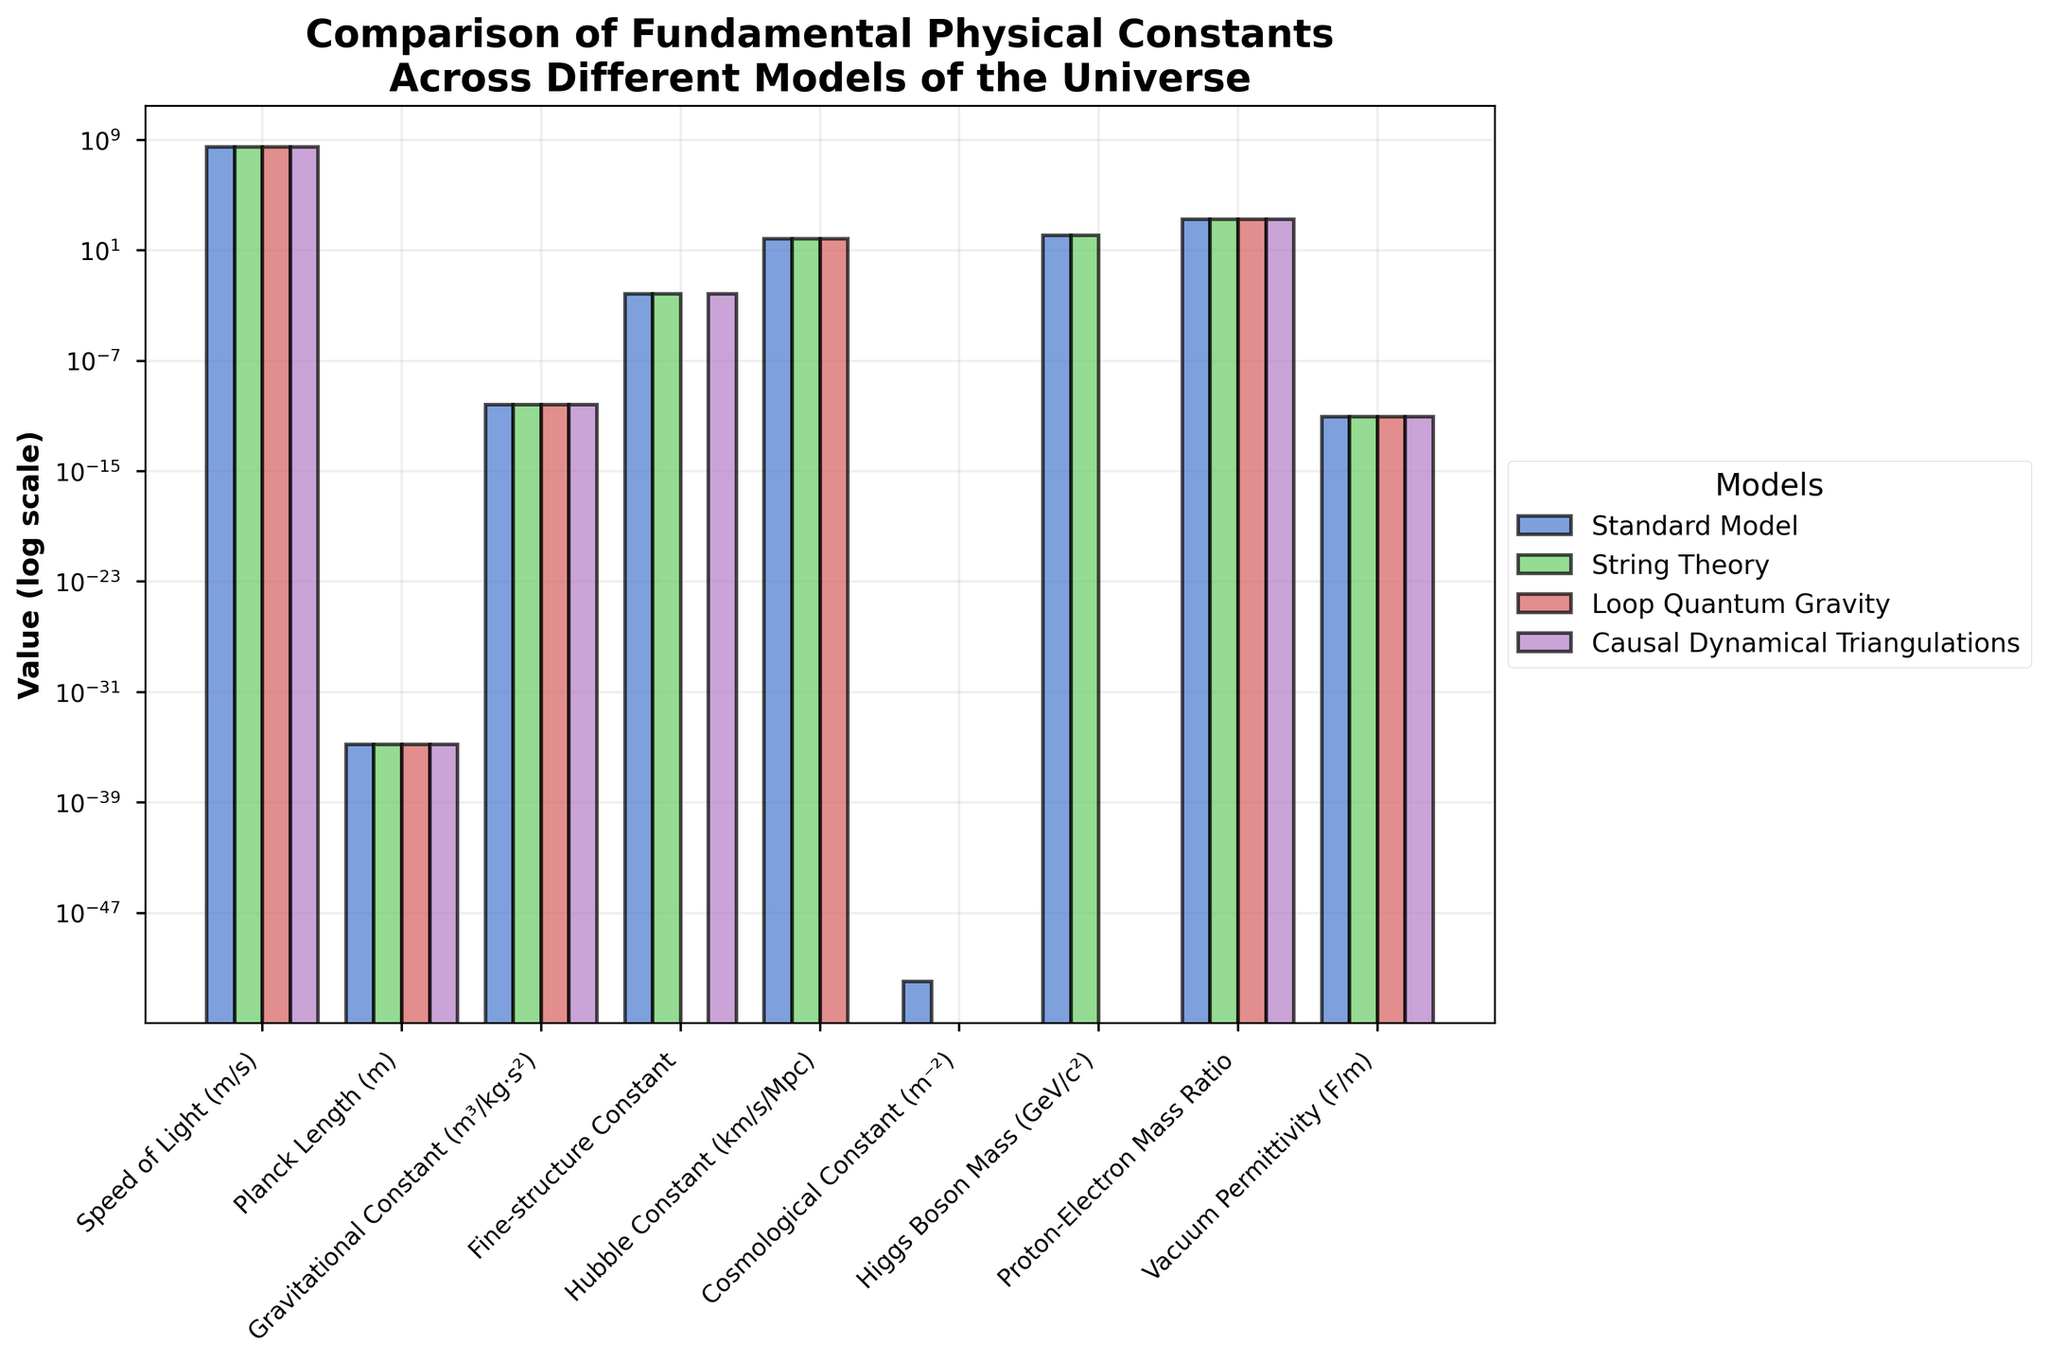Which model has the unique value of the Fine-structure Constant? In the figure, locate the bars representing the Fine-structure Constant. Observe that most models have the same value, but Loop Quantum Gravity has a varied value, making it unique.
Answer: Loop Quantum Gravity What is the difference between the Hubble Constants in String Theory and Causal Dynamical Triangulations? Examine the bars corresponding to the Hubble Constant for both String Theory and Causal Dynamical Triangulations. Note that String Theory has a fixed value of 67.4, while Causal Dynamical Triangulations varies. Since variation implies uncertainty, we can’t quantify a specific numerical difference.
Answer: Varies Which constants have exactly the same value across all models? Observe the heights of the bars for each constant across all models. The Speed of Light, Planck Length, Gravitational Constant, and Proton-Electron Mass Ratio have the same height for each model, indicating identical values.
Answer: Speed of Light, Planck Length, Gravitational Constant, Proton-Electron Mass Ratio Which model shows a zero value for the Cosmological Constant? Identify the bars that represent the Cosmological Constant. For String Theory, the height of the bar is at the bottom, indicating a zero value for the Cosmological Constant.
Answer: String Theory How does the Higgs Boson Mass differ between the Standard Model and Loop Quantum Gravity? Inspect the bars corresponding to the Higgs Boson Mass. The Standard Model has a visible bar at 125.10 GeV/c², while Loop Quantum Gravity shows a zero height bar, indicating the Higgs Boson Mass is not applicable in Loop Quantum Gravity.
Answer: Not Applicable What is the average value of the Gravitational Constant across all models? Since the Gravitational Constant is identical in all models, the value is consistent at 6.67430e-11 m³/kg·s². The average of the same value remains the same.
Answer: 6.67430e-11 m³/kg·s² Compare the Vacuum Permittivity across all models. Are there any differences? Find the bars for Vacuum Permittivity across all models. All bars are at the same height, indicating identical values across all models.
Answer: No differences Which constant shows a quantized value in Loop Quantum Gravity? Locate the bars for Loop Quantum Gravity and search for any labels or variations. The Cosmological Constant bar is labeled "Quantized," indicating its specific value in this model.
Answer: Cosmological Constant 